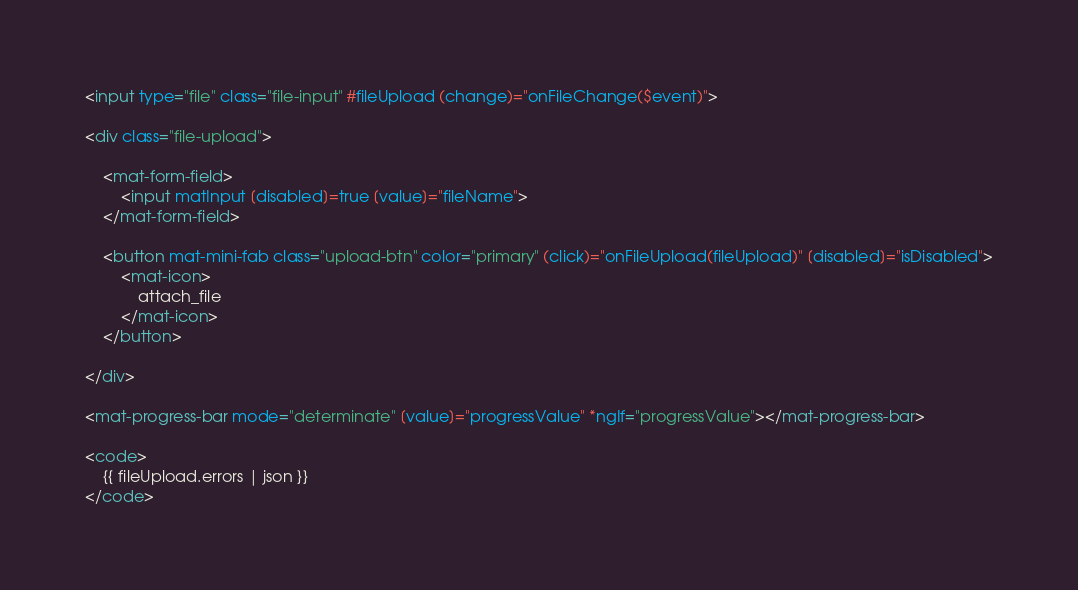<code> <loc_0><loc_0><loc_500><loc_500><_HTML_>
<input type="file" class="file-input" #fileUpload (change)="onFileChange($event)">

<div class="file-upload">

    <mat-form-field>
        <input matInput [disabled]=true [value]="fileName">
    </mat-form-field>

    <button mat-mini-fab class="upload-btn" color="primary" (click)="onFileUpload(fileUpload)" [disabled]="isDisabled">
        <mat-icon>
            attach_file
        </mat-icon>
    </button>

</div>

<mat-progress-bar mode="determinate" [value]="progressValue" *ngIf="progressValue"></mat-progress-bar>

<code>
    {{ fileUpload.errors | json }}
</code>
</code> 